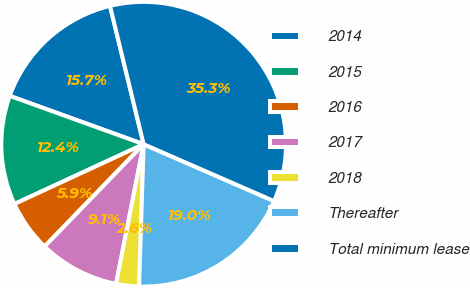Convert chart. <chart><loc_0><loc_0><loc_500><loc_500><pie_chart><fcel>2014<fcel>2015<fcel>2016<fcel>2017<fcel>2018<fcel>Thereafter<fcel>Total minimum lease<nl><fcel>15.69%<fcel>12.41%<fcel>5.86%<fcel>9.14%<fcel>2.59%<fcel>18.96%<fcel>35.34%<nl></chart> 